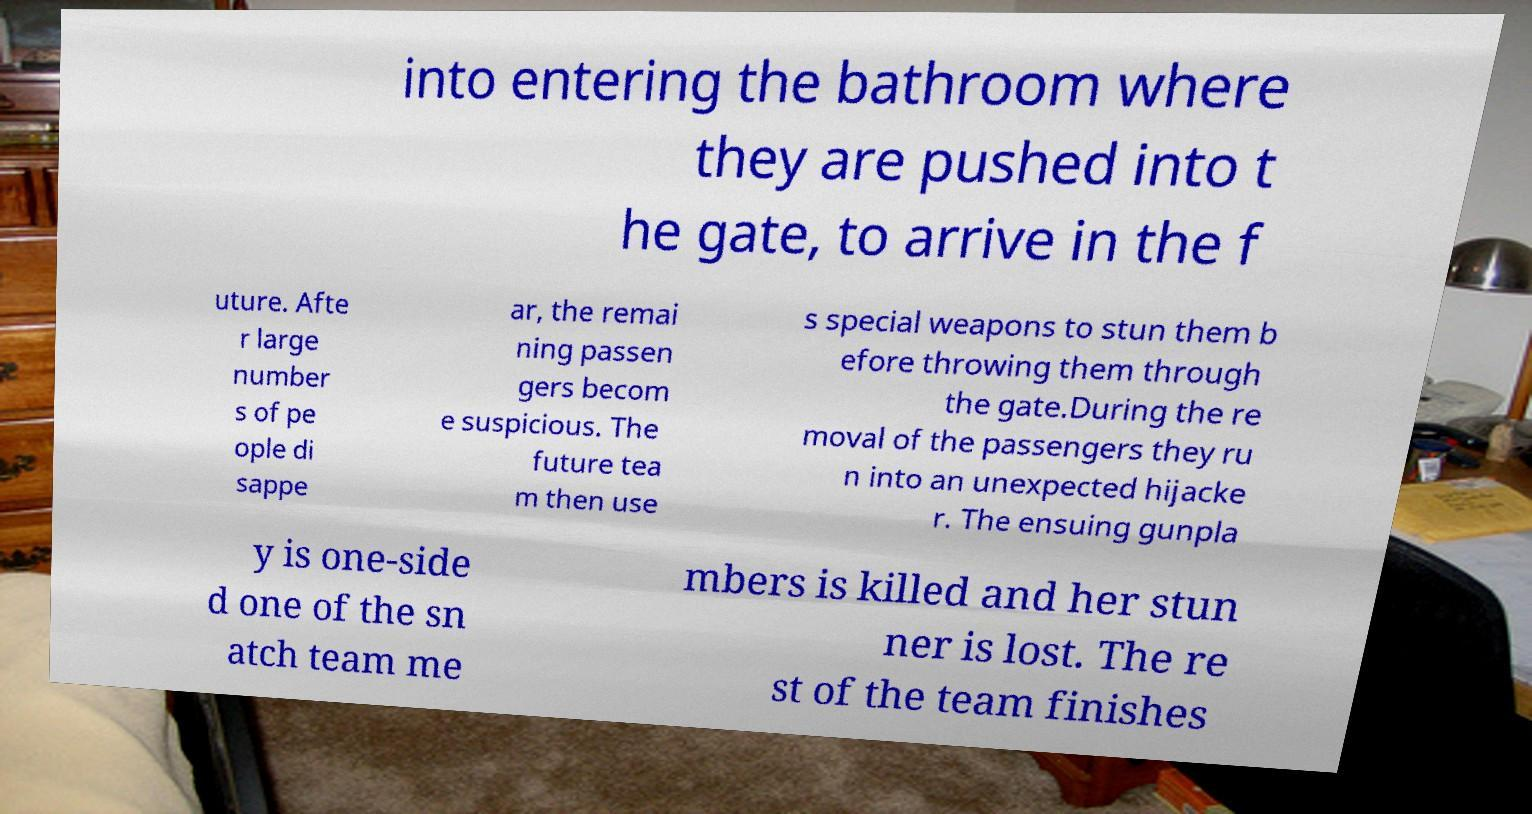Can you accurately transcribe the text from the provided image for me? into entering the bathroom where they are pushed into t he gate, to arrive in the f uture. Afte r large number s of pe ople di sappe ar, the remai ning passen gers becom e suspicious. The future tea m then use s special weapons to stun them b efore throwing them through the gate.During the re moval of the passengers they ru n into an unexpected hijacke r. The ensuing gunpla y is one-side d one of the sn atch team me mbers is killed and her stun ner is lost. The re st of the team finishes 